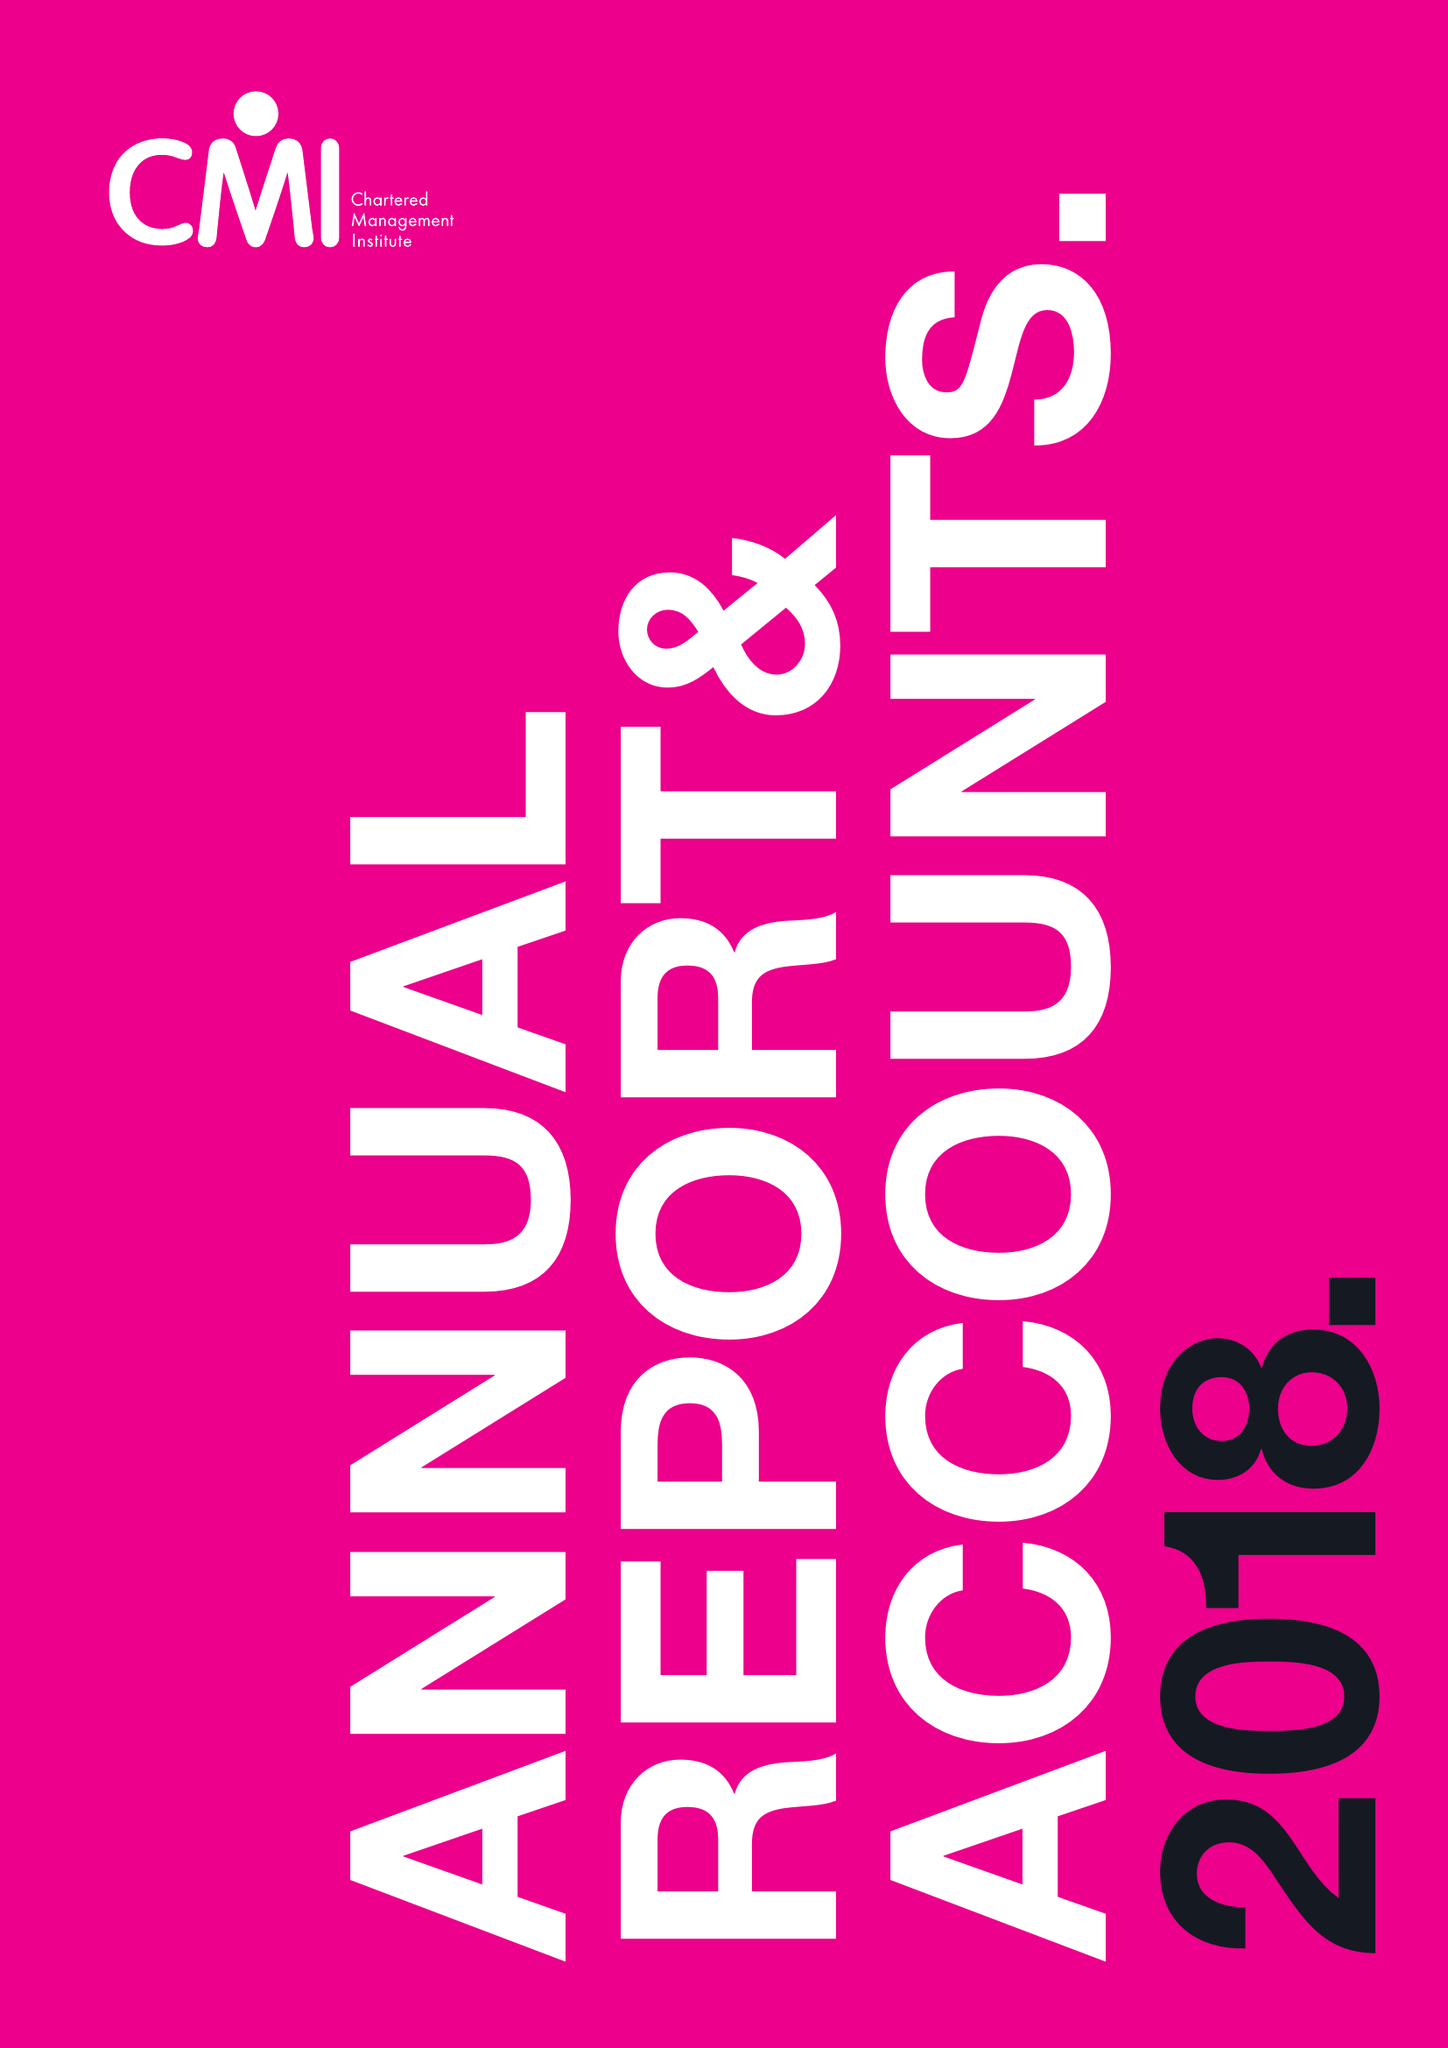What is the value for the income_annually_in_british_pounds?
Answer the question using a single word or phrase. 14561000.00 